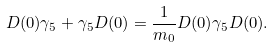<formula> <loc_0><loc_0><loc_500><loc_500>D ( 0 ) \gamma _ { 5 } + \gamma _ { 5 } D ( 0 ) = \frac { 1 } { m _ { 0 } } D ( 0 ) \gamma _ { 5 } D ( 0 ) .</formula> 